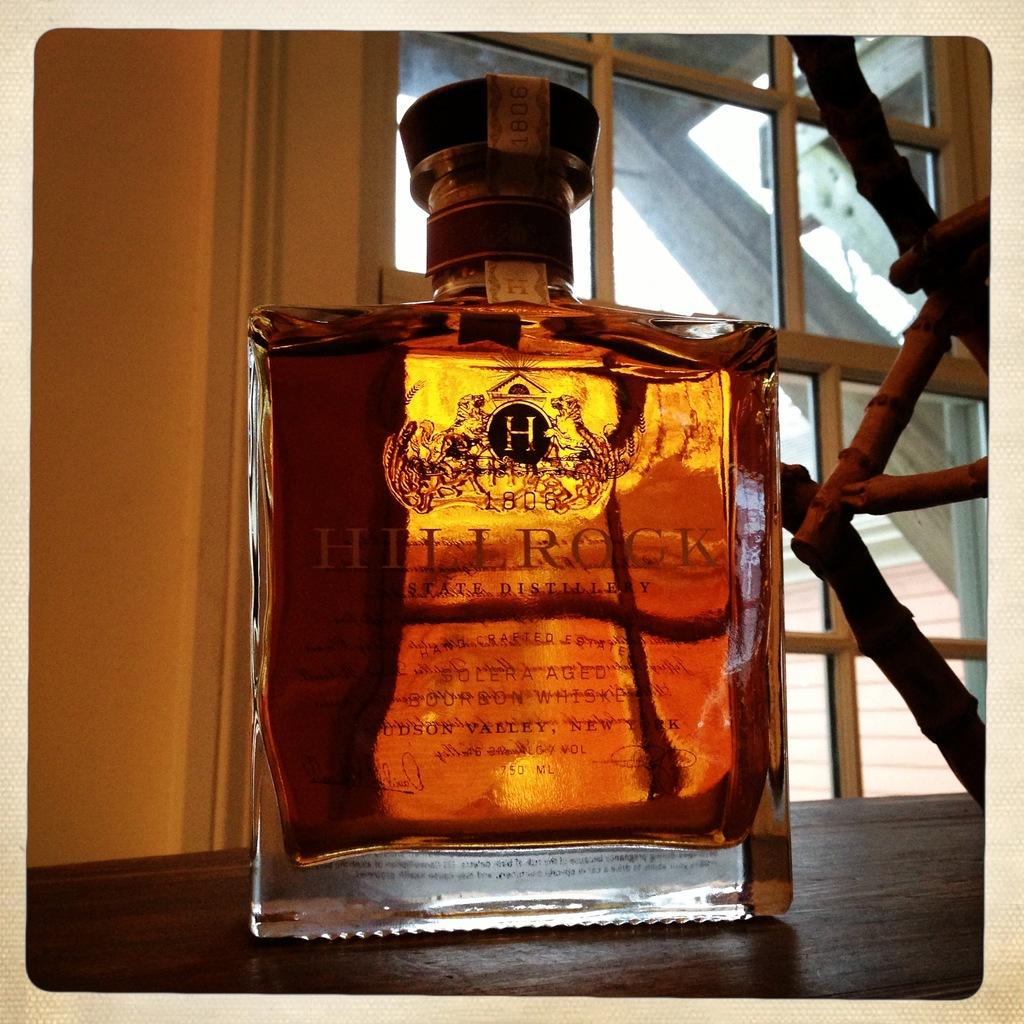What is the main object in the image? There is a wine bottle in the image. On what surface is the wine bottle placed? The wine bottle is on a wooden surface. What can be seen in the background of the image? There is a window and a wall in the image. How many beans are visible in the image? There are no beans present in the image. What type of net is used to catch the wine bottle in the image? There is no net present in the image, and the wine bottle is not being caught. 